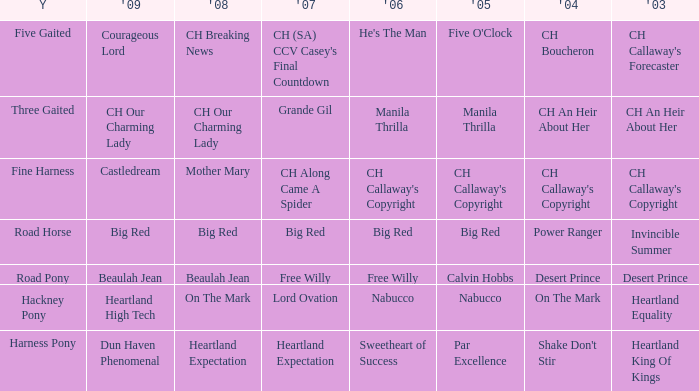What is the 2008 for the 2009 ch our charming lady? CH Our Charming Lady. Parse the full table. {'header': ['Y', "'09", "'08", "'07", "'06", "'05", "'04", "'03"], 'rows': [['Five Gaited', 'Courageous Lord', 'CH Breaking News', "CH (SA) CCV Casey's Final Countdown", "He's The Man", "Five O'Clock", 'CH Boucheron', "CH Callaway's Forecaster"], ['Three Gaited', 'CH Our Charming Lady', 'CH Our Charming Lady', 'Grande Gil', 'Manila Thrilla', 'Manila Thrilla', 'CH An Heir About Her', 'CH An Heir About Her'], ['Fine Harness', 'Castledream', 'Mother Mary', 'CH Along Came A Spider', "CH Callaway's Copyright", "CH Callaway's Copyright", "CH Callaway's Copyright", "CH Callaway's Copyright"], ['Road Horse', 'Big Red', 'Big Red', 'Big Red', 'Big Red', 'Big Red', 'Power Ranger', 'Invincible Summer'], ['Road Pony', 'Beaulah Jean', 'Beaulah Jean', 'Free Willy', 'Free Willy', 'Calvin Hobbs', 'Desert Prince', 'Desert Prince'], ['Hackney Pony', 'Heartland High Tech', 'On The Mark', 'Lord Ovation', 'Nabucco', 'Nabucco', 'On The Mark', 'Heartland Equality'], ['Harness Pony', 'Dun Haven Phenomenal', 'Heartland Expectation', 'Heartland Expectation', 'Sweetheart of Success', 'Par Excellence', "Shake Don't Stir", 'Heartland King Of Kings']]} 